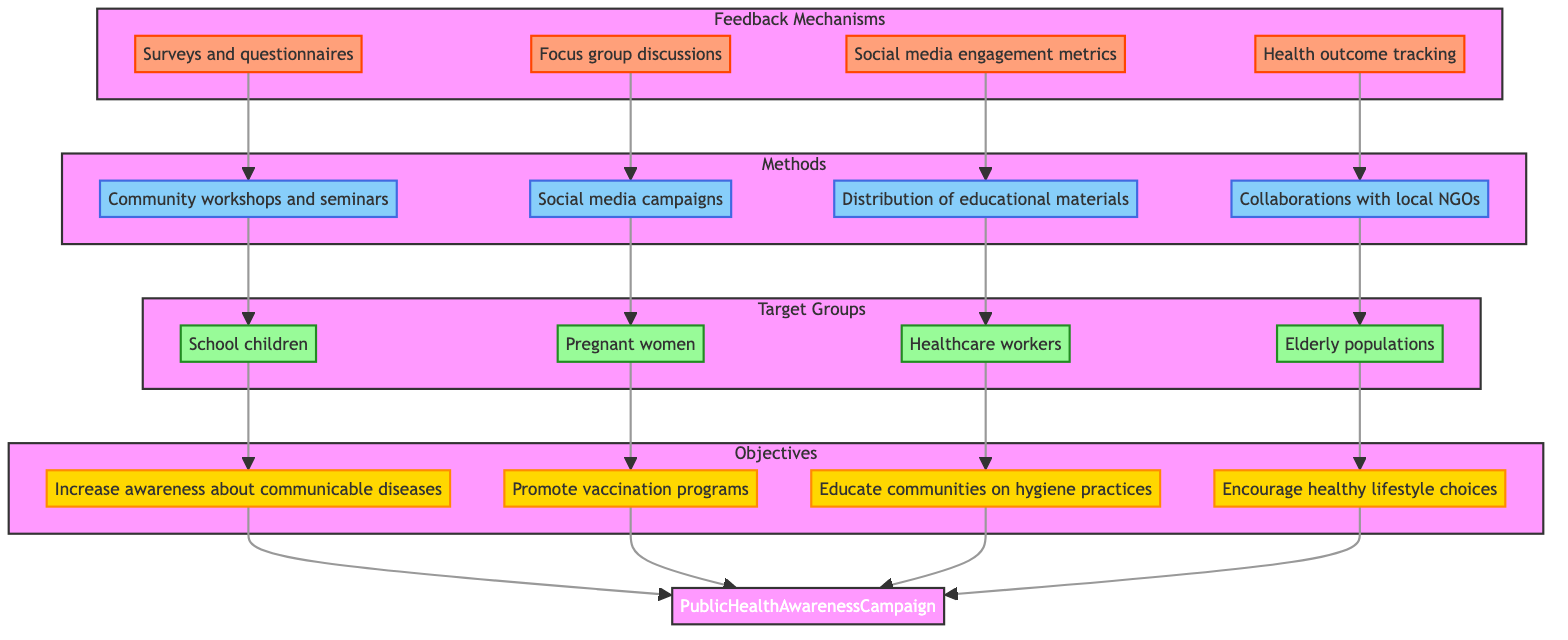What are the objectives of the Public Health Awareness Campaign? The diagram displays four main objectives listed under the "Objectives" subgraph: to increase awareness about communicable diseases, promote vaccination programs, educate communities on hygiene practices, and encourage healthy lifestyle choices.
Answer: Increase awareness about communicable diseases, promote vaccination programs, educate communities on hygiene practices, encourage healthy lifestyle choices How many target groups are identified? By examining the "Target Groups" subgraph, we can count four distinct groups: school children, pregnant women, healthcare workers, and elderly populations.
Answer: 4 Which method is linked to focus group discussions? The arrow from "Focus group discussions" in the "Feedback Mechanisms" subgraph points towards "Social media campaigns" in the "Methods" subgraph, indicating this connection.
Answer: Social media campaigns What is the relationship between school children and objectives? The "Target Groups" node for school children has a direct connection to the objectives node for increasing awareness about communicable diseases, indicating that school children are targeted to achieve this specific objective.
Answer: Increase awareness about communicable diseases Which target group is associated with promoting vaccination programs? The diagram shows that "Pregnant women" are the target group linked directly to the objective of promoting vaccination programs.
Answer: Pregnant women What feedback mechanism relates to health outcome tracking? The "Health outcome tracking" node is part of the "Feedback Mechanisms" subgraph and connects to the method "Collaborations with local NGOs" in the "Methods" subgraph, displaying this relationship.
Answer: Collaborations with local NGOs What number of methods are used to achieve feedback? In the "Methods" subgraph, there are four methods listed, indicating that this number of methods is employed for achieving feedback.
Answer: 4 Identify a method targeted at elderly populations. The diagram indicates that "Collaborations with local NGOs" is specifically used to reach elderly populations, as shown by the directed arrows linking both nodes.
Answer: Collaborations with local NGOs Which objective is achieved through educational materials? The "Distribution of educational materials" method in the "Methods" subgraph directly connects to the target group of "Healthcare workers," with the ultimate aim tied to the objective of educating communities on hygiene practices.
Answer: Educate communities on hygiene practices 